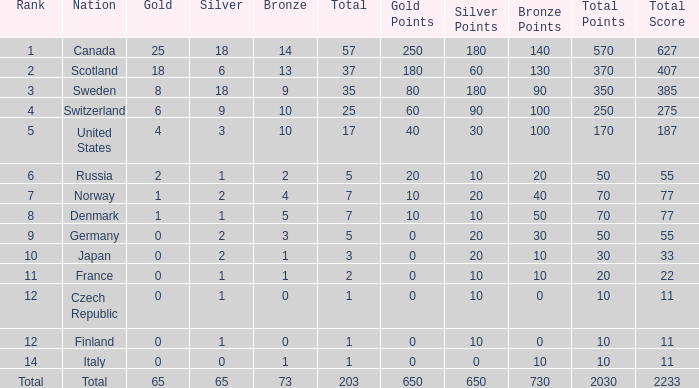What is the total number of medals when there are 18 gold medals? 37.0. 